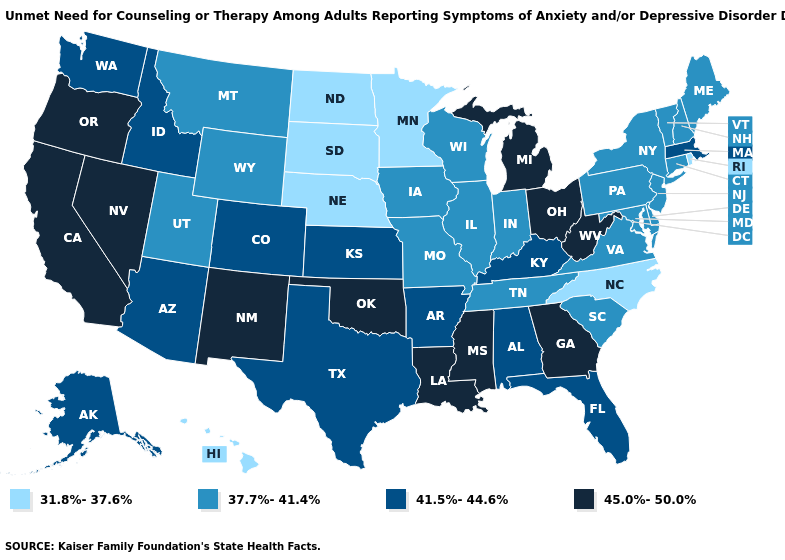Name the states that have a value in the range 37.7%-41.4%?
Write a very short answer. Connecticut, Delaware, Illinois, Indiana, Iowa, Maine, Maryland, Missouri, Montana, New Hampshire, New Jersey, New York, Pennsylvania, South Carolina, Tennessee, Utah, Vermont, Virginia, Wisconsin, Wyoming. What is the value of Tennessee?
Keep it brief. 37.7%-41.4%. What is the value of California?
Quick response, please. 45.0%-50.0%. Which states have the lowest value in the USA?
Be succinct. Hawaii, Minnesota, Nebraska, North Carolina, North Dakota, Rhode Island, South Dakota. Which states have the lowest value in the Northeast?
Answer briefly. Rhode Island. Does Tennessee have a higher value than South Dakota?
Answer briefly. Yes. What is the value of Oregon?
Keep it brief. 45.0%-50.0%. What is the value of Georgia?
Short answer required. 45.0%-50.0%. What is the lowest value in states that border Kansas?
Answer briefly. 31.8%-37.6%. What is the highest value in the USA?
Concise answer only. 45.0%-50.0%. What is the lowest value in states that border Vermont?
Answer briefly. 37.7%-41.4%. Name the states that have a value in the range 31.8%-37.6%?
Write a very short answer. Hawaii, Minnesota, Nebraska, North Carolina, North Dakota, Rhode Island, South Dakota. What is the value of New Mexico?
Concise answer only. 45.0%-50.0%. Is the legend a continuous bar?
Short answer required. No. Which states have the highest value in the USA?
Concise answer only. California, Georgia, Louisiana, Michigan, Mississippi, Nevada, New Mexico, Ohio, Oklahoma, Oregon, West Virginia. 